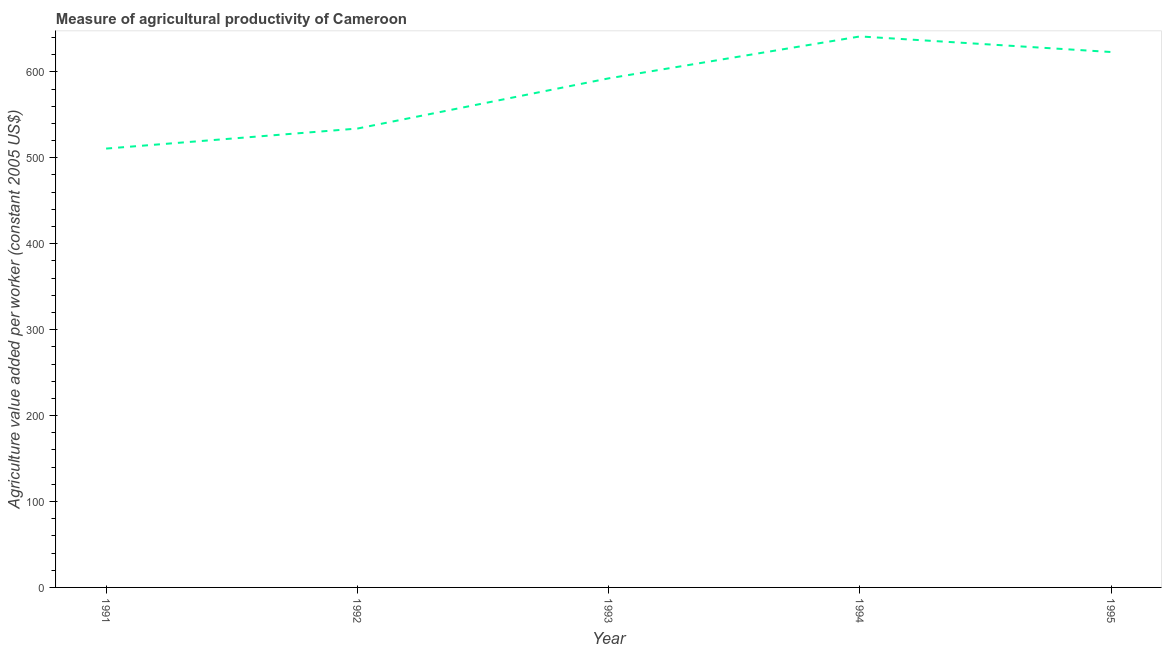What is the agriculture value added per worker in 1993?
Your response must be concise. 592.47. Across all years, what is the maximum agriculture value added per worker?
Your response must be concise. 641.26. Across all years, what is the minimum agriculture value added per worker?
Give a very brief answer. 510.73. In which year was the agriculture value added per worker maximum?
Your answer should be compact. 1994. What is the sum of the agriculture value added per worker?
Ensure brevity in your answer.  2901.61. What is the difference between the agriculture value added per worker in 1991 and 1995?
Offer a very short reply. -112.38. What is the average agriculture value added per worker per year?
Ensure brevity in your answer.  580.32. What is the median agriculture value added per worker?
Provide a short and direct response. 592.47. Do a majority of the years between 1994 and 1992 (inclusive) have agriculture value added per worker greater than 40 US$?
Offer a terse response. No. What is the ratio of the agriculture value added per worker in 1993 to that in 1994?
Keep it short and to the point. 0.92. Is the difference between the agriculture value added per worker in 1991 and 1994 greater than the difference between any two years?
Keep it short and to the point. Yes. What is the difference between the highest and the second highest agriculture value added per worker?
Provide a succinct answer. 18.14. Is the sum of the agriculture value added per worker in 1994 and 1995 greater than the maximum agriculture value added per worker across all years?
Provide a succinct answer. Yes. What is the difference between the highest and the lowest agriculture value added per worker?
Your answer should be very brief. 130.52. How many lines are there?
Provide a short and direct response. 1. What is the difference between two consecutive major ticks on the Y-axis?
Ensure brevity in your answer.  100. Does the graph contain grids?
Your response must be concise. No. What is the title of the graph?
Keep it short and to the point. Measure of agricultural productivity of Cameroon. What is the label or title of the Y-axis?
Ensure brevity in your answer.  Agriculture value added per worker (constant 2005 US$). What is the Agriculture value added per worker (constant 2005 US$) of 1991?
Offer a very short reply. 510.73. What is the Agriculture value added per worker (constant 2005 US$) in 1992?
Provide a succinct answer. 534.04. What is the Agriculture value added per worker (constant 2005 US$) in 1993?
Provide a short and direct response. 592.47. What is the Agriculture value added per worker (constant 2005 US$) in 1994?
Make the answer very short. 641.26. What is the Agriculture value added per worker (constant 2005 US$) in 1995?
Your answer should be very brief. 623.11. What is the difference between the Agriculture value added per worker (constant 2005 US$) in 1991 and 1992?
Provide a succinct answer. -23.31. What is the difference between the Agriculture value added per worker (constant 2005 US$) in 1991 and 1993?
Your answer should be compact. -81.73. What is the difference between the Agriculture value added per worker (constant 2005 US$) in 1991 and 1994?
Offer a very short reply. -130.52. What is the difference between the Agriculture value added per worker (constant 2005 US$) in 1991 and 1995?
Your answer should be very brief. -112.38. What is the difference between the Agriculture value added per worker (constant 2005 US$) in 1992 and 1993?
Provide a short and direct response. -58.42. What is the difference between the Agriculture value added per worker (constant 2005 US$) in 1992 and 1994?
Keep it short and to the point. -107.21. What is the difference between the Agriculture value added per worker (constant 2005 US$) in 1992 and 1995?
Your answer should be very brief. -89.07. What is the difference between the Agriculture value added per worker (constant 2005 US$) in 1993 and 1994?
Provide a succinct answer. -48.79. What is the difference between the Agriculture value added per worker (constant 2005 US$) in 1993 and 1995?
Offer a very short reply. -30.65. What is the difference between the Agriculture value added per worker (constant 2005 US$) in 1994 and 1995?
Make the answer very short. 18.14. What is the ratio of the Agriculture value added per worker (constant 2005 US$) in 1991 to that in 1992?
Make the answer very short. 0.96. What is the ratio of the Agriculture value added per worker (constant 2005 US$) in 1991 to that in 1993?
Offer a very short reply. 0.86. What is the ratio of the Agriculture value added per worker (constant 2005 US$) in 1991 to that in 1994?
Keep it short and to the point. 0.8. What is the ratio of the Agriculture value added per worker (constant 2005 US$) in 1991 to that in 1995?
Offer a terse response. 0.82. What is the ratio of the Agriculture value added per worker (constant 2005 US$) in 1992 to that in 1993?
Offer a terse response. 0.9. What is the ratio of the Agriculture value added per worker (constant 2005 US$) in 1992 to that in 1994?
Keep it short and to the point. 0.83. What is the ratio of the Agriculture value added per worker (constant 2005 US$) in 1992 to that in 1995?
Keep it short and to the point. 0.86. What is the ratio of the Agriculture value added per worker (constant 2005 US$) in 1993 to that in 1994?
Give a very brief answer. 0.92. What is the ratio of the Agriculture value added per worker (constant 2005 US$) in 1993 to that in 1995?
Offer a terse response. 0.95. 